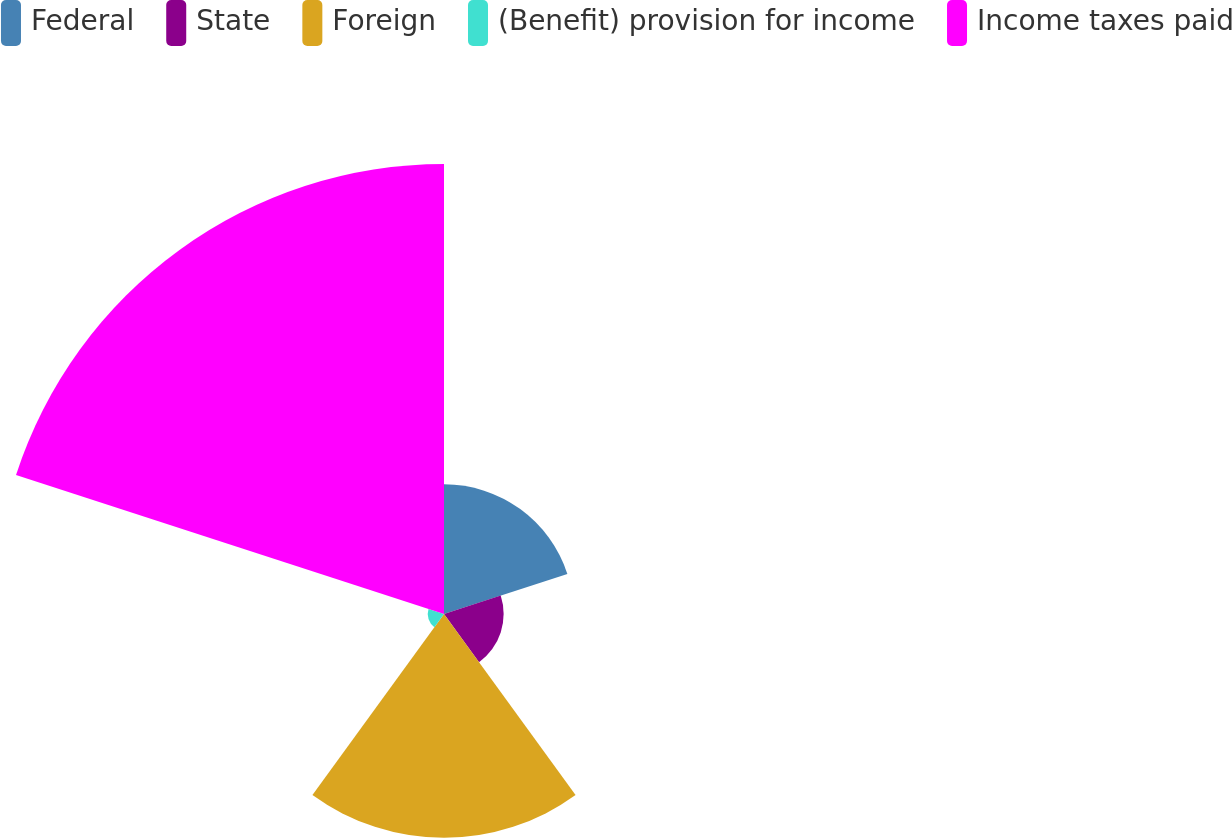Convert chart. <chart><loc_0><loc_0><loc_500><loc_500><pie_chart><fcel>Federal<fcel>State<fcel>Foreign<fcel>(Benefit) provision for income<fcel>Income taxes paid<nl><fcel>14.75%<fcel>6.78%<fcel>25.45%<fcel>1.85%<fcel>51.17%<nl></chart> 